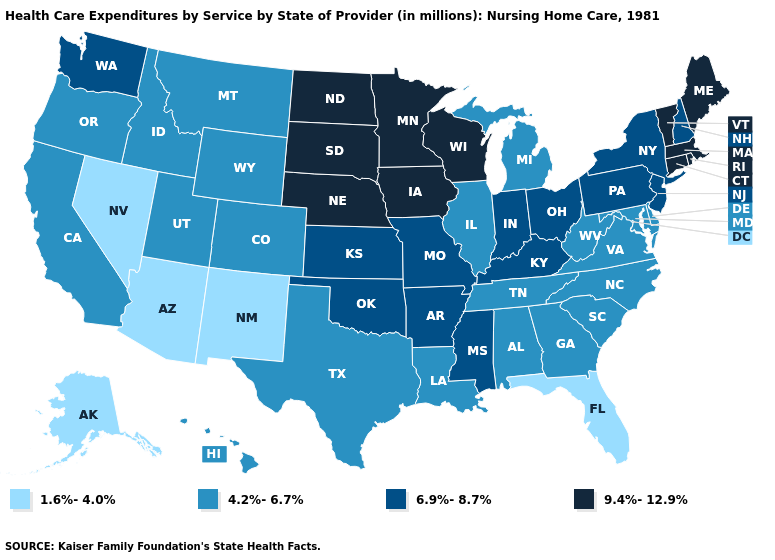Name the states that have a value in the range 4.2%-6.7%?
Keep it brief. Alabama, California, Colorado, Delaware, Georgia, Hawaii, Idaho, Illinois, Louisiana, Maryland, Michigan, Montana, North Carolina, Oregon, South Carolina, Tennessee, Texas, Utah, Virginia, West Virginia, Wyoming. Name the states that have a value in the range 9.4%-12.9%?
Write a very short answer. Connecticut, Iowa, Maine, Massachusetts, Minnesota, Nebraska, North Dakota, Rhode Island, South Dakota, Vermont, Wisconsin. How many symbols are there in the legend?
Short answer required. 4. Name the states that have a value in the range 4.2%-6.7%?
Short answer required. Alabama, California, Colorado, Delaware, Georgia, Hawaii, Idaho, Illinois, Louisiana, Maryland, Michigan, Montana, North Carolina, Oregon, South Carolina, Tennessee, Texas, Utah, Virginia, West Virginia, Wyoming. Which states have the highest value in the USA?
Concise answer only. Connecticut, Iowa, Maine, Massachusetts, Minnesota, Nebraska, North Dakota, Rhode Island, South Dakota, Vermont, Wisconsin. What is the value of Nebraska?
Give a very brief answer. 9.4%-12.9%. Does Washington have the highest value in the West?
Give a very brief answer. Yes. What is the value of Mississippi?
Quick response, please. 6.9%-8.7%. Among the states that border Kentucky , which have the highest value?
Concise answer only. Indiana, Missouri, Ohio. What is the value of Indiana?
Short answer required. 6.9%-8.7%. Among the states that border North Carolina , which have the lowest value?
Concise answer only. Georgia, South Carolina, Tennessee, Virginia. What is the value of Texas?
Write a very short answer. 4.2%-6.7%. What is the highest value in the South ?
Answer briefly. 6.9%-8.7%. What is the highest value in states that border Minnesota?
Be succinct. 9.4%-12.9%. 